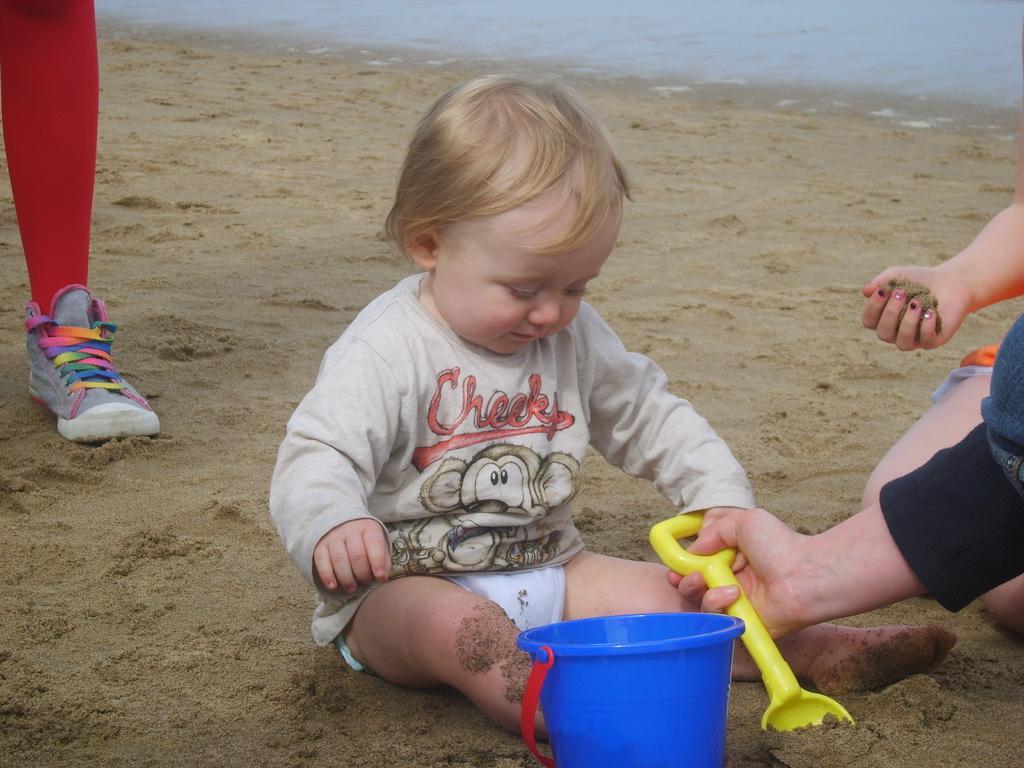In one or two sentences, can you explain what this image depicts? In this picture I can see small boy sitting on the sand and there is a blue bucket and there is a yellow color object and this person is holding it and in the background there is a ocean and there are is a person here on the left. 